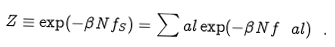Convert formula to latex. <formula><loc_0><loc_0><loc_500><loc_500>Z \equiv \exp ( - \beta N f _ { S } ) = \sum _ { \ } a l \exp ( - \beta N f _ { \ } a l ) \ .</formula> 